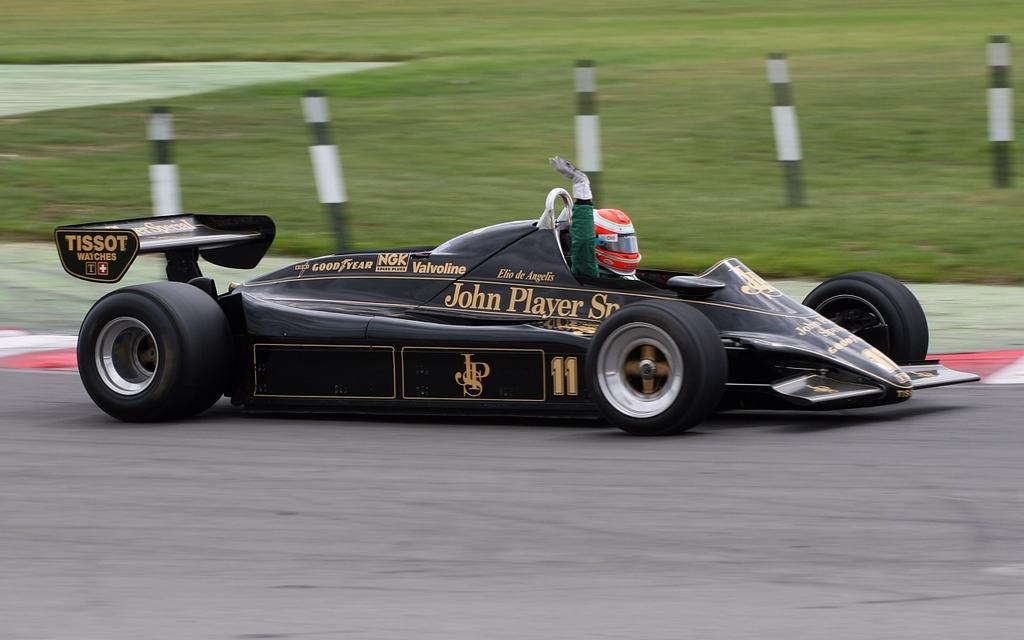In one or two sentences, can you explain what this image depicts? In this image we can see a person wearing a helmet sitting in a sports car placed on the road. On the backside we can see some poles and grass. 